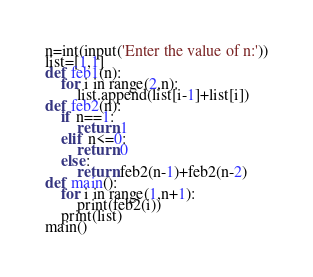Convert code to text. <code><loc_0><loc_0><loc_500><loc_500><_Python_>n=int(input('Enter the value of n:'))
list=[1,1]
def feb1(n):
	for i in range(2,n):
		list.append(list[i-1]+list[i])
def feb2(n):
	if n==1:
		return 1
	elif n<=0:
		return 0
	else:
		return feb2(n-1)+feb2(n-2)
def main():
	for i in range(1,n+1):
		print(feb2(i))
	print(list)
main()</code> 